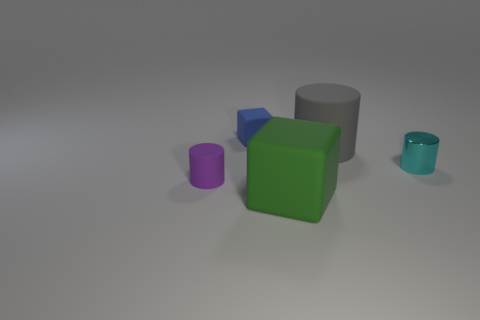Add 1 purple rubber objects. How many objects exist? 6 Subtract all cylinders. How many objects are left? 2 Subtract all tiny green matte spheres. Subtract all green blocks. How many objects are left? 4 Add 4 large rubber blocks. How many large rubber blocks are left? 5 Add 4 big green cubes. How many big green cubes exist? 5 Subtract 0 red cylinders. How many objects are left? 5 